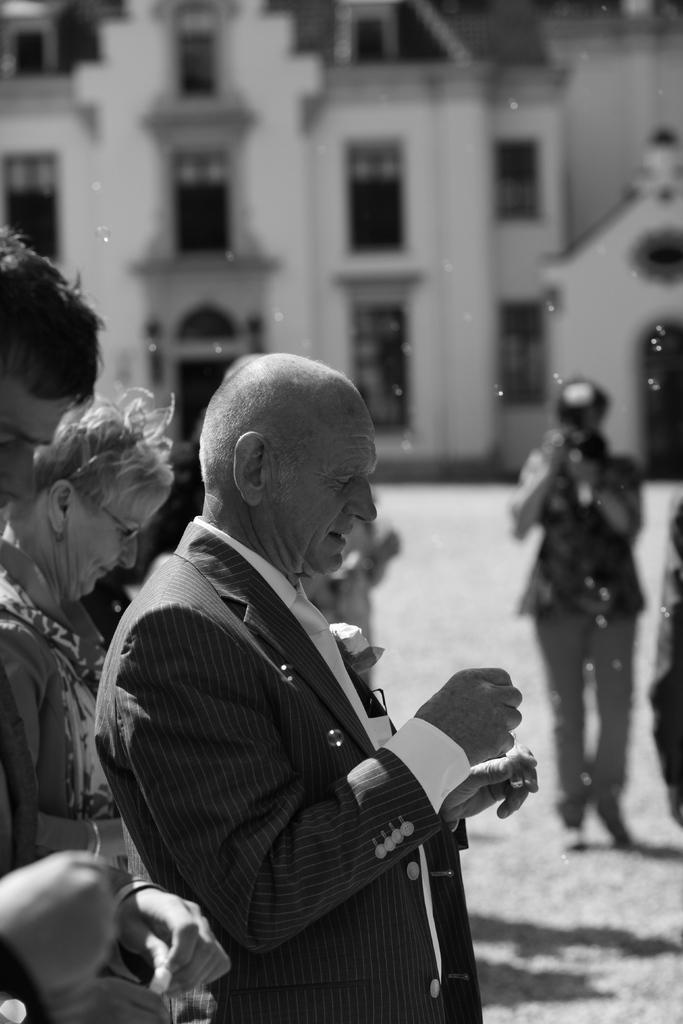Please provide a concise description of this image. This is black and white picture,there are people standing holding an objects and this person holding camera. In this background we can see building and windows. 